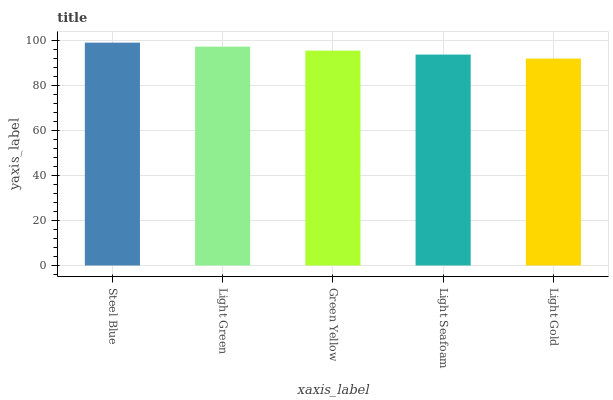Is Light Gold the minimum?
Answer yes or no. Yes. Is Steel Blue the maximum?
Answer yes or no. Yes. Is Light Green the minimum?
Answer yes or no. No. Is Light Green the maximum?
Answer yes or no. No. Is Steel Blue greater than Light Green?
Answer yes or no. Yes. Is Light Green less than Steel Blue?
Answer yes or no. Yes. Is Light Green greater than Steel Blue?
Answer yes or no. No. Is Steel Blue less than Light Green?
Answer yes or no. No. Is Green Yellow the high median?
Answer yes or no. Yes. Is Green Yellow the low median?
Answer yes or no. Yes. Is Light Gold the high median?
Answer yes or no. No. Is Steel Blue the low median?
Answer yes or no. No. 